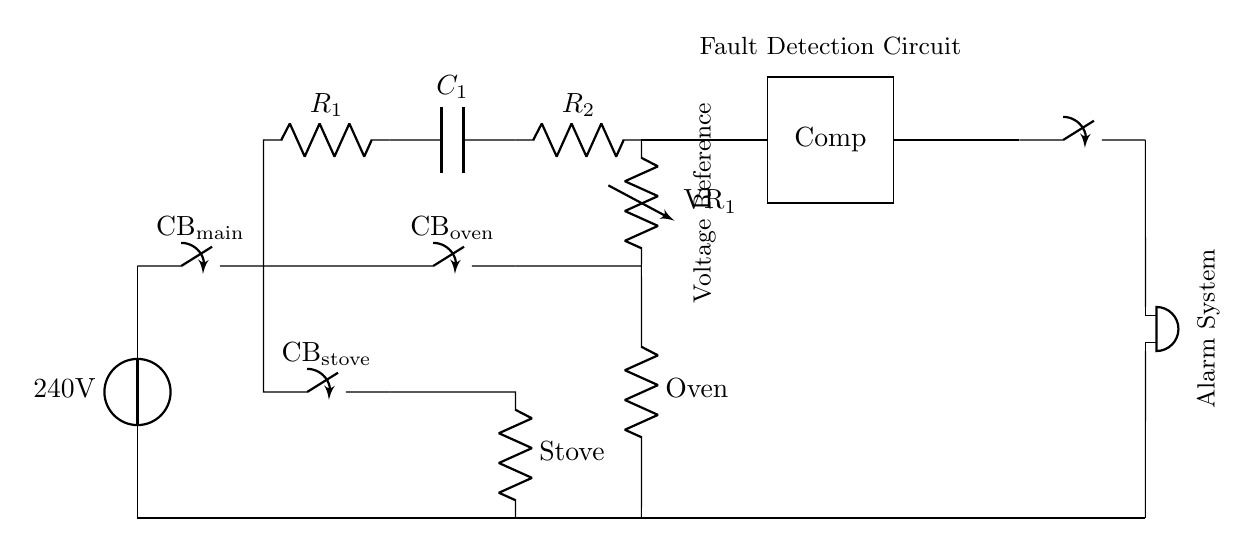What is the main power source voltage? The main power source voltage is indicated as 240V in the circuit diagram, which is a standard voltage for commercial appliances.
Answer: 240V What components are used for the fault detection circuit? The components for the fault detection circuit include two resistors (R1 and R2) and a capacitor (C1), which are essential for sensing voltage variations due to faults.
Answer: R1, C1, R2 How many circuit breakers are shown in the diagram? There are three circuit breakers in the diagram: the main circuit breaker (CB_main), the oven circuit breaker (CB_oven), and the stove circuit breaker (CB_stove).
Answer: Three What happens when a fault is detected? When a fault is detected, the comparator will activate the closing switch leading to the buzzer, which serves as an alarm system to alert users of the fault in the oven or stove.
Answer: Alarm activation What is the purpose of the capacitor in the fault detection circuit? The capacitor (C1) in the fault detection circuit helps stabilize voltage levels and can store energy, which is crucial for ensuring that the circuit can respond accurately to transient changes in voltage that might indicate a fault.
Answer: Stabilize voltage How does the comparator function in this circuit? The comparator receives input from the voltage reference and determines if the input voltage exceeds a predefined threshold level. If so, it activates the output to trigger the alarm system, indicating a fault condition.
Answer: Fault detection Which component acts as the load in the oven circuit? The oven is the load in the oven circuit; it is represented by the resistor labeled as "Oven," where electrical energy is converted into heat during cooking.
Answer: Oven 